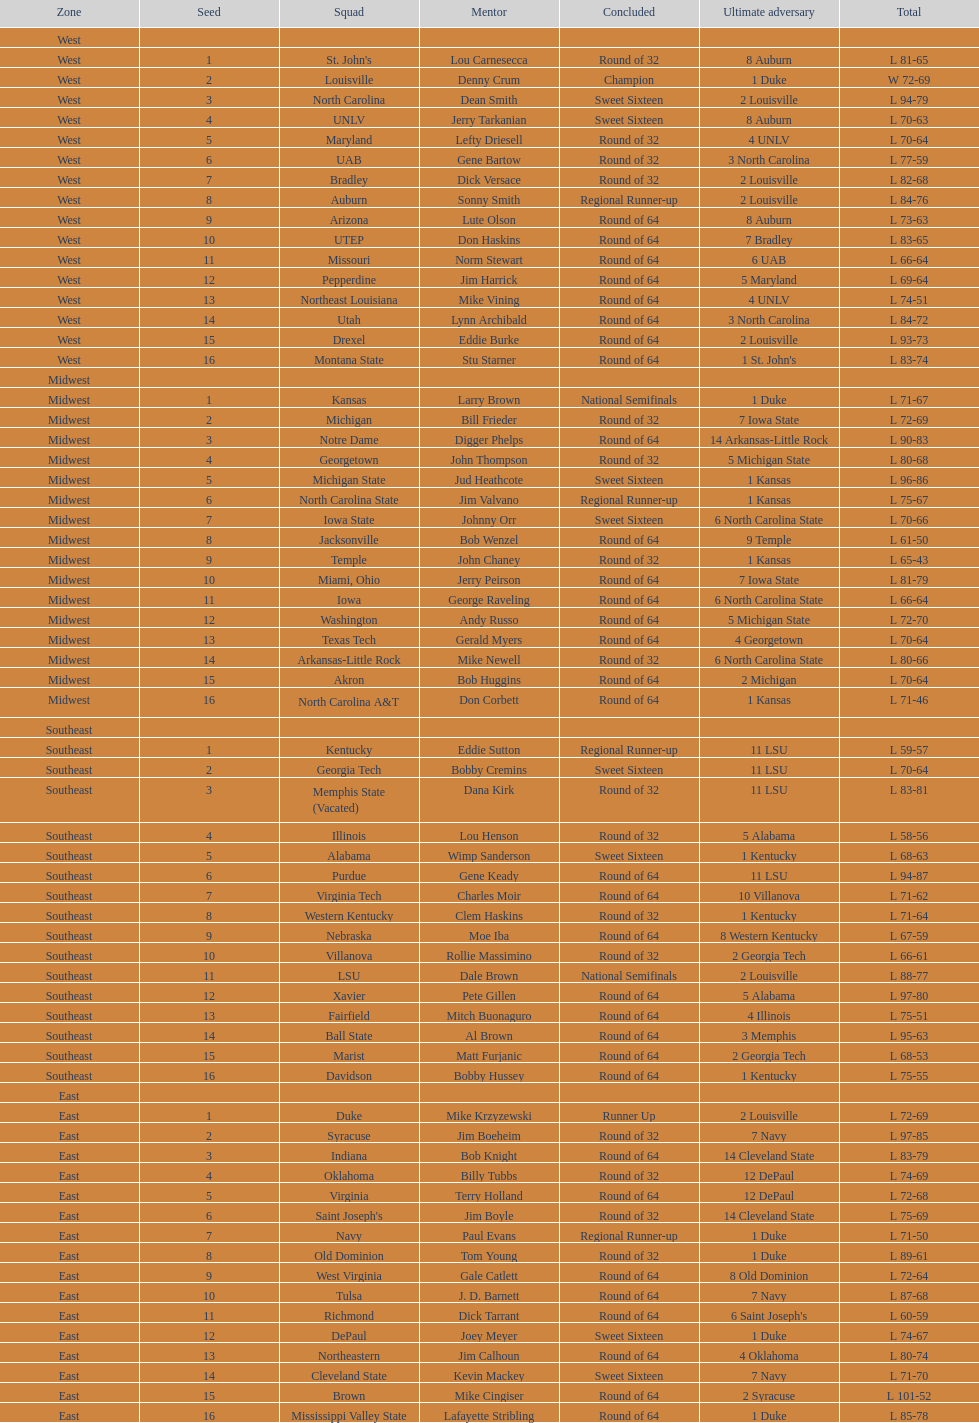How many teams are in the east region. 16. 